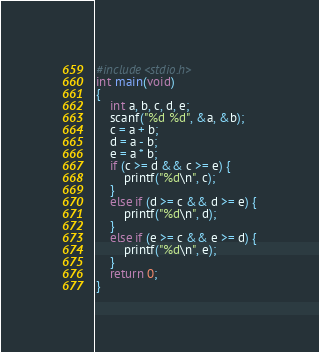<code> <loc_0><loc_0><loc_500><loc_500><_C_>#include<stdio.h>
int main(void)
{
	int a, b, c, d, e;
	scanf("%d %d", &a, &b);
	c = a + b;
	d = a - b;
	e = a * b;
	if (c >= d && c >= e) {
		printf("%d\n", c);
	}
	else if (d >= c && d >= e) {
		printf("%d\n", d);
	}
	else if (e >= c && e >= d) {
		printf("%d\n", e);
	}
	return 0;
}</code> 